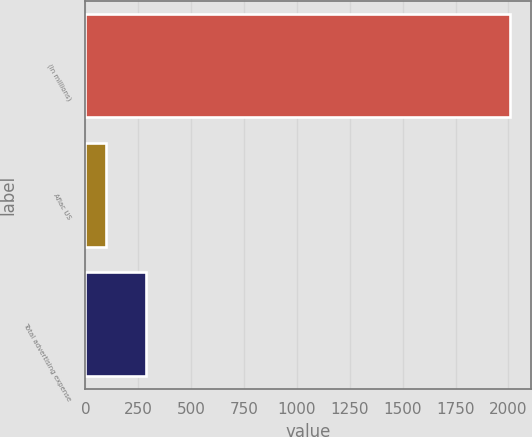Convert chart to OTSL. <chart><loc_0><loc_0><loc_500><loc_500><bar_chart><fcel>(In millions)<fcel>Aflac US<fcel>Total advertising expense<nl><fcel>2007<fcel>95<fcel>286.2<nl></chart> 